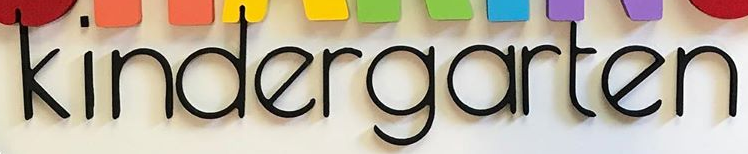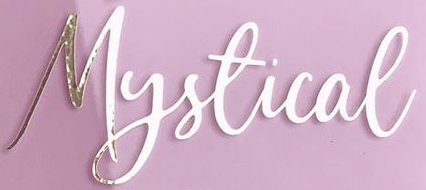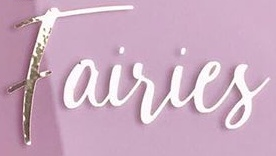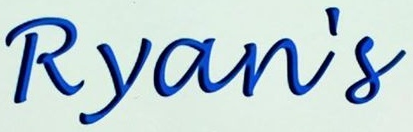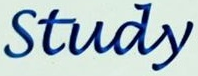What text appears in these images from left to right, separated by a semicolon? kindergarten; Mystical; Fairies; Ryan's; Study 